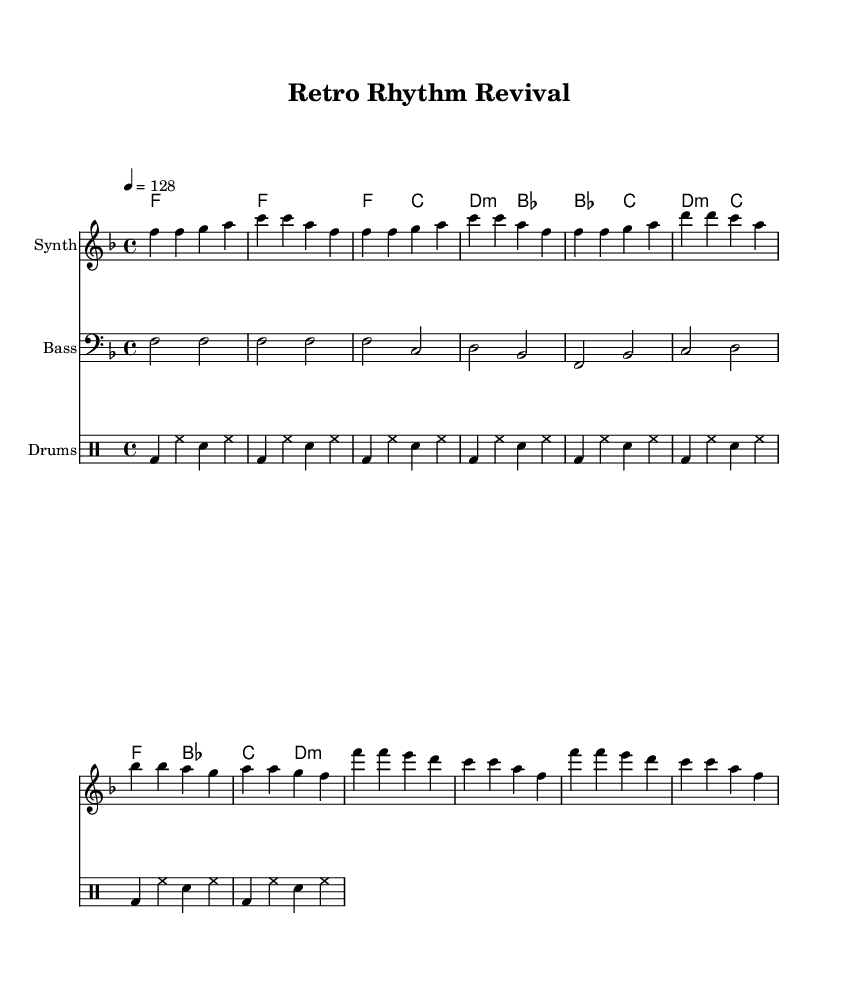What is the key signature of this music? The key signature indicated is F major, which has one flat (B flat). This can be determined by looking at the key signature section of the sheet music at the beginning.
Answer: F major What is the time signature of this piece? The time signature is 4/4, as indicated at the beginning of the music. This means there are four beats in each measure and the quarter note gets one beat.
Answer: 4/4 What is the tempo indicated for this piece? The tempo marking indicates a speed of 128 beats per minute, shown as "4 = 128" in the header section of the sheet music.
Answer: 128 How many measures are in the verse section? The verse section consists of four measures, which can be counted by examining the melody line. Each grouping of notes separated by vertical lines represents a measure.
Answer: 4 Which part has the clef designated as bass? The bassline is labeled with a bass clef, as indicated in the score section of the sheet music. The clef is specifically identified in the main staff for the bass part, making it clear that this part follows bass clef notation.
Answer: Bass What is the starting note of the chorus melody? The chorus melody begins on the note F, which is the first note of the measure listed for the chorus section. Observing the melody line indicates that F is the first note played.
Answer: F What is the overall theme of the lyrics? The lyrics revolve around nostalgia and the joy of dancing, which is evident from the phrases and sentiments expressed in the text portion of the sheet music. The words capture a sense of returning to joyful experiences of the past.
Answer: Nostalgia 